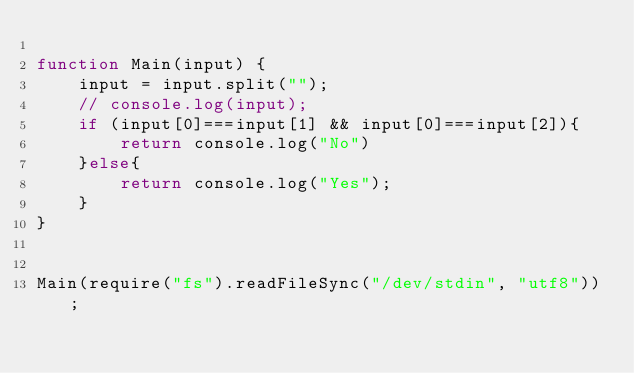<code> <loc_0><loc_0><loc_500><loc_500><_JavaScript_>
function Main(input) {
    input = input.split("");
    // console.log(input);
	if (input[0]===input[1] && input[0]===input[2]){
	    return console.log("No")
	}else{
	    return console.log("Yes");
	}
}
 
 
Main(require("fs").readFileSync("/dev/stdin", "utf8"));</code> 